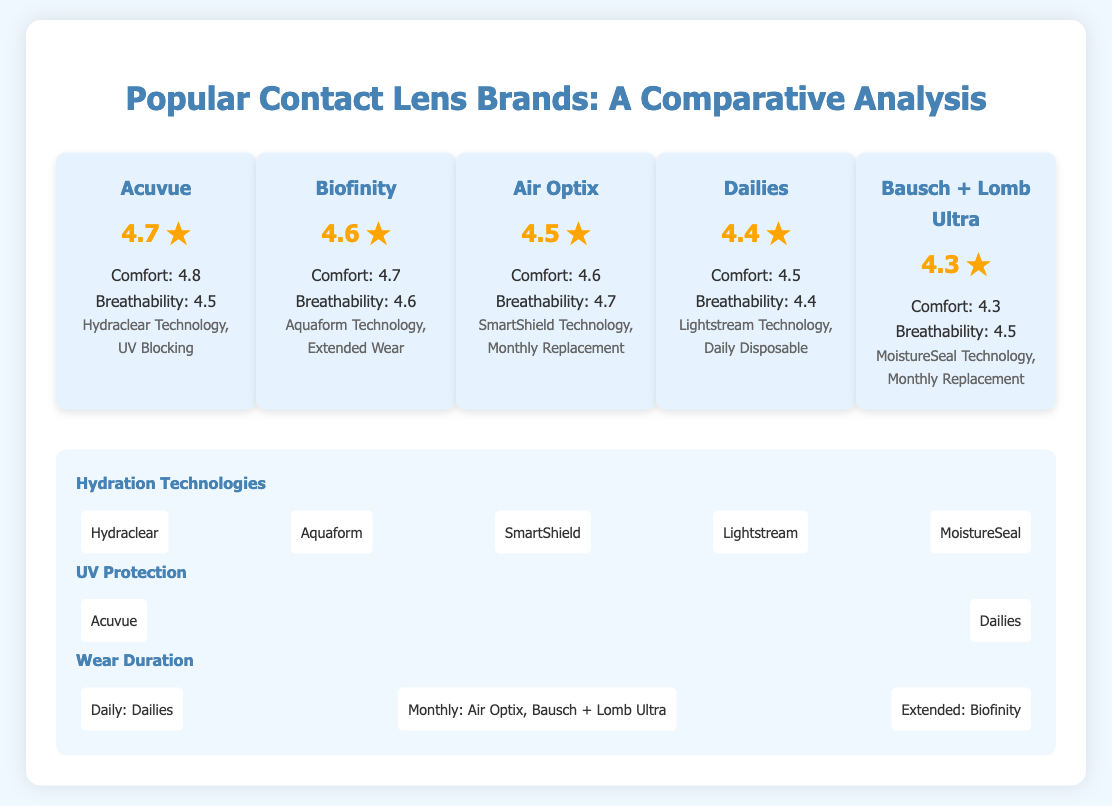What is the highest rating among the contact lens brands? The document lists the ratings, and Acuvue has the highest rating of 4.7 stars.
Answer: 4.7 ★ Which contact lens brand features MoistureSeal Technology? The feature list in the document shows that Bausch + Lomb Ultra includes MoistureSeal Technology.
Answer: Bausch + Lomb Ultra What is the comfort rating of Biofinity? The comfort rating provided in the document for Biofinity is 4.7.
Answer: 4.7 How many brands offer monthly replacement lenses? The document states that two brands, Air Optix and Bausch + Lomb Ultra, offer monthly replacement lenses.
Answer: 2 Which lens brand has the lowest breathability rating? Comparing the breathability ratings, Dailies has the lowest rating of 4.4.
Answer: Dailies What hydration technology does Acuvue use? According to the document, Acuvue uses Hydraclear Technology for hydration.
Answer: Hydraclear What is the wear duration for Dailies? The document specifies that Dailies are categorized as daily disposable lenses.
Answer: Daily Which brand is associated with Extended Wear? The comparison of features indicates that Biofinity is associated with Extended Wear.
Answer: Biofinity How many brands provide UV protection? The document shows that two brands, Acuvue and Dailies, provide UV protection.
Answer: 2 